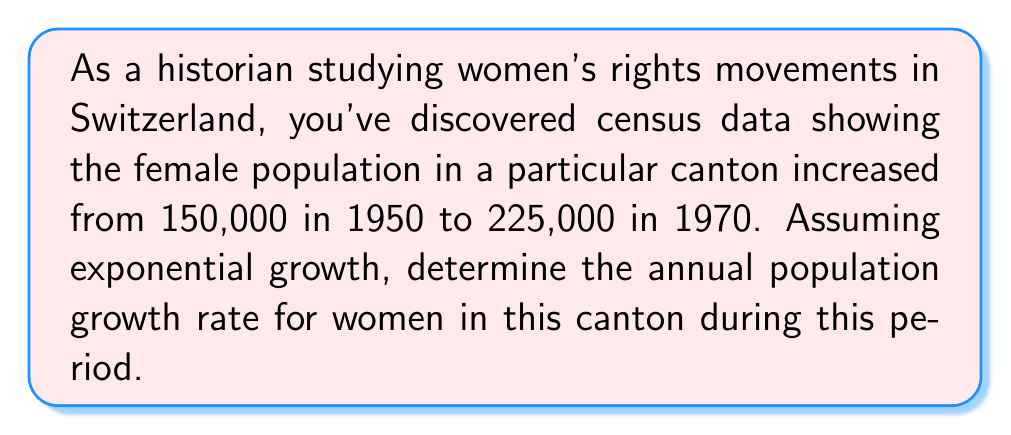Show me your answer to this math problem. To solve this problem, we'll use the exponential growth formula and follow these steps:

1. The exponential growth formula is:
   $$P(t) = P_0 \cdot e^{rt}$$
   where $P(t)$ is the population at time $t$, $P_0$ is the initial population, $r$ is the growth rate, and $t$ is the time period.

2. We know:
   $P_0 = 150,000$ (initial population in 1950)
   $P(t) = 225,000$ (final population in 1970)
   $t = 20$ years

3. Substitute these values into the formula:
   $$225,000 = 150,000 \cdot e^{20r}$$

4. Divide both sides by 150,000:
   $$1.5 = e^{20r}$$

5. Take the natural logarithm of both sides:
   $$\ln(1.5) = 20r$$

6. Solve for $r$:
   $$r = \frac{\ln(1.5)}{20}$$

7. Calculate the value:
   $$r = \frac{0.4054651081}{20} = 0.02027325541$$

8. Convert to a percentage:
   $$r \approx 0.02027 \cdot 100\% = 2.027\%$$
Answer: 2.027% per year 